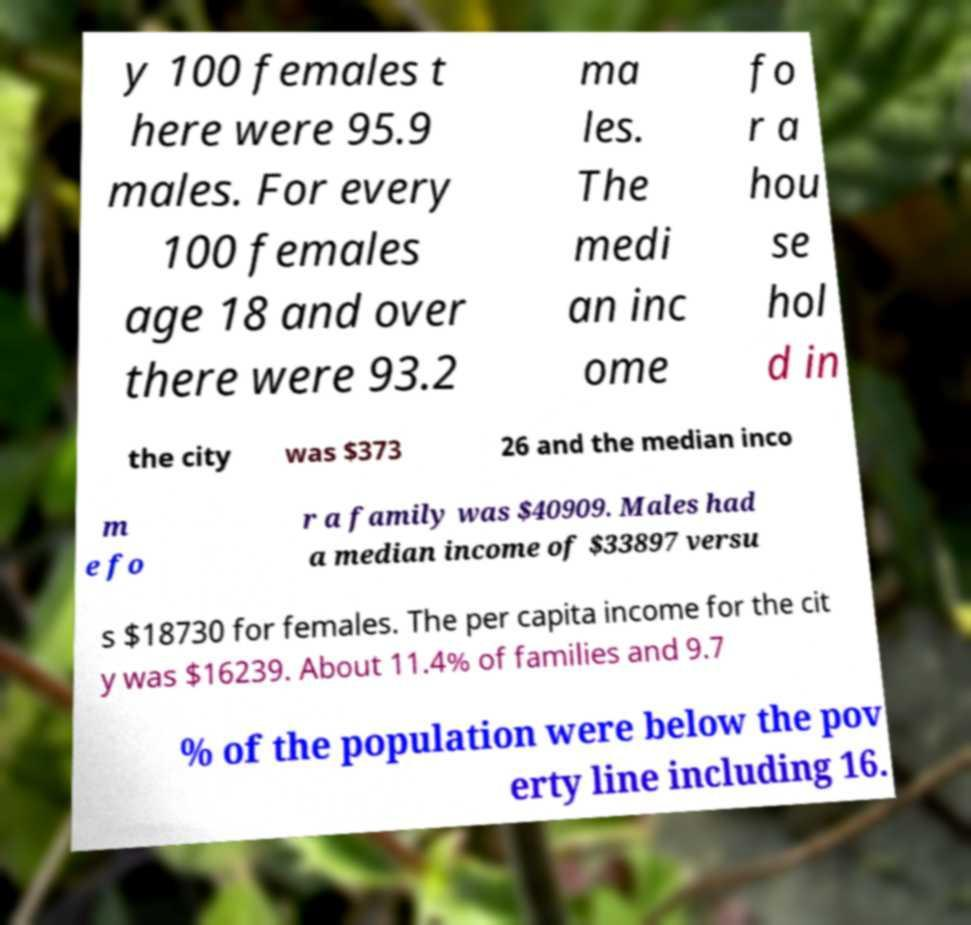Could you assist in decoding the text presented in this image and type it out clearly? y 100 females t here were 95.9 males. For every 100 females age 18 and over there were 93.2 ma les. The medi an inc ome fo r a hou se hol d in the city was $373 26 and the median inco m e fo r a family was $40909. Males had a median income of $33897 versu s $18730 for females. The per capita income for the cit y was $16239. About 11.4% of families and 9.7 % of the population were below the pov erty line including 16. 